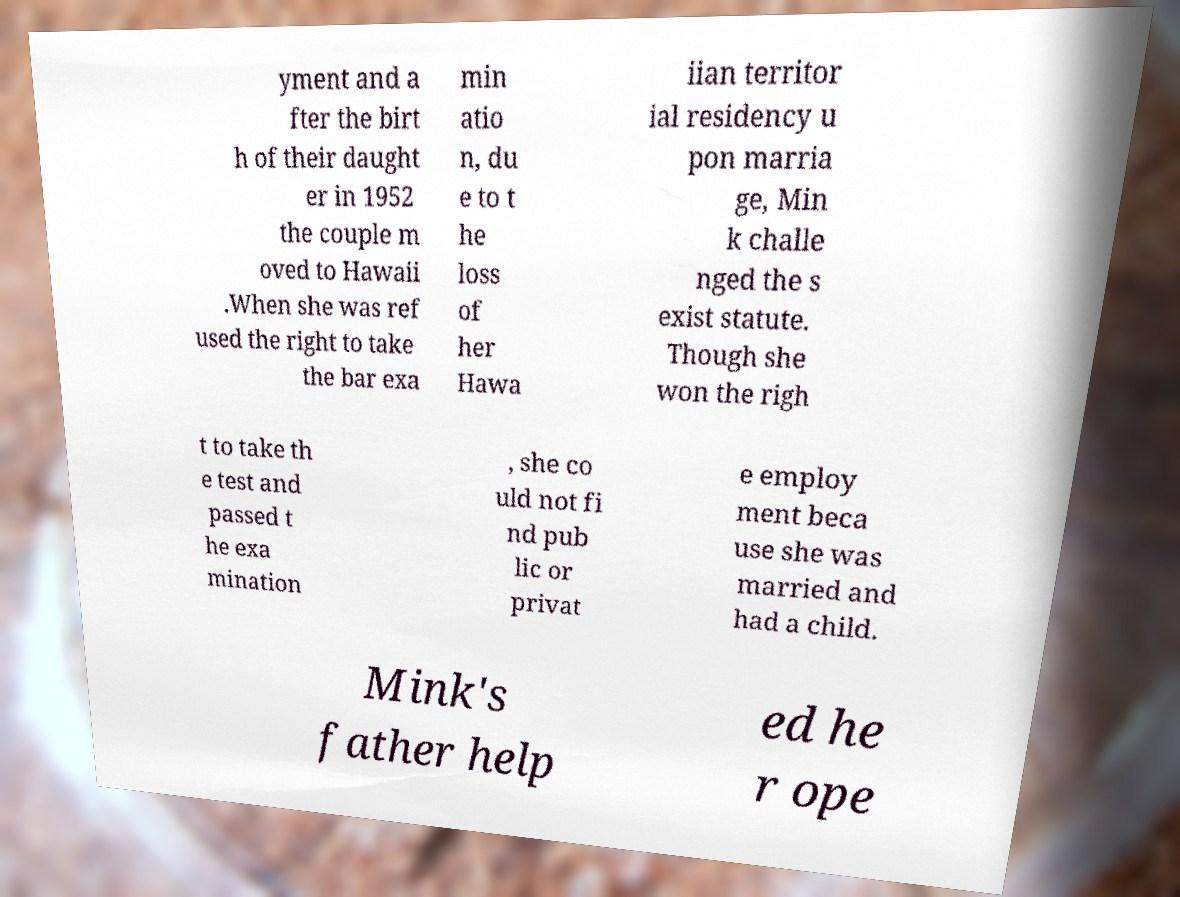I need the written content from this picture converted into text. Can you do that? yment and a fter the birt h of their daught er in 1952 the couple m oved to Hawaii .When she was ref used the right to take the bar exa min atio n, du e to t he loss of her Hawa iian territor ial residency u pon marria ge, Min k challe nged the s exist statute. Though she won the righ t to take th e test and passed t he exa mination , she co uld not fi nd pub lic or privat e employ ment beca use she was married and had a child. Mink's father help ed he r ope 